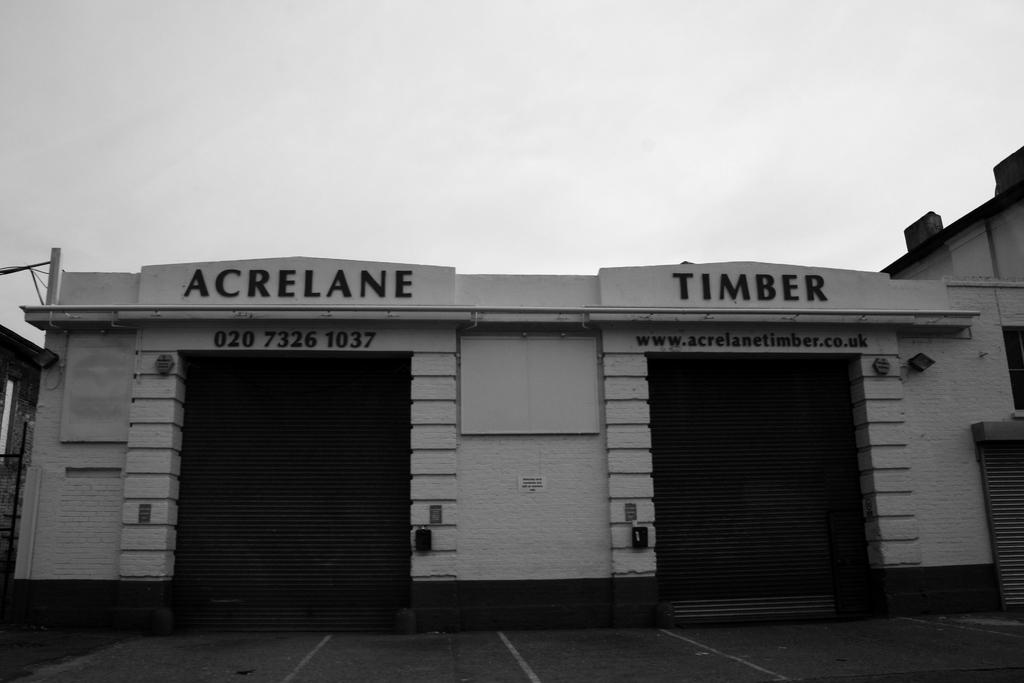What is the color scheme of the image? The image is black and white. What can be seen at the bottom of the image? There is a road at the bottom of the image. What type of structures are present in the image? There are buildings in the image. What are the name boards on walls used for? Name boards on walls are used to display names or information about the buildings or businesses. What is the purpose of the lights in the image? The lights are present to provide illumination in the area. What are the poles and electric wires used for? The poles and electric wires are used to support and transmit electricity. What are the shutters used for? The shutters are used to cover windows or doors for security or privacy. What can be seen in the sky in the image? Clouds are visible in the sky. How many clams can be seen on the road in the image? There are no clams present on the road in the image. What type of boat is visible in the image? There is no boat present in the image. 